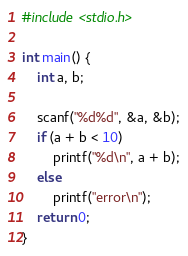Convert code to text. <code><loc_0><loc_0><loc_500><loc_500><_C_>#include <stdio.h>

int main() {
	int a, b;

	scanf("%d%d", &a, &b);
	if (a + b < 10)
		printf("%d\n", a + b);
	else
		printf("error\n");
	return 0;
}
</code> 